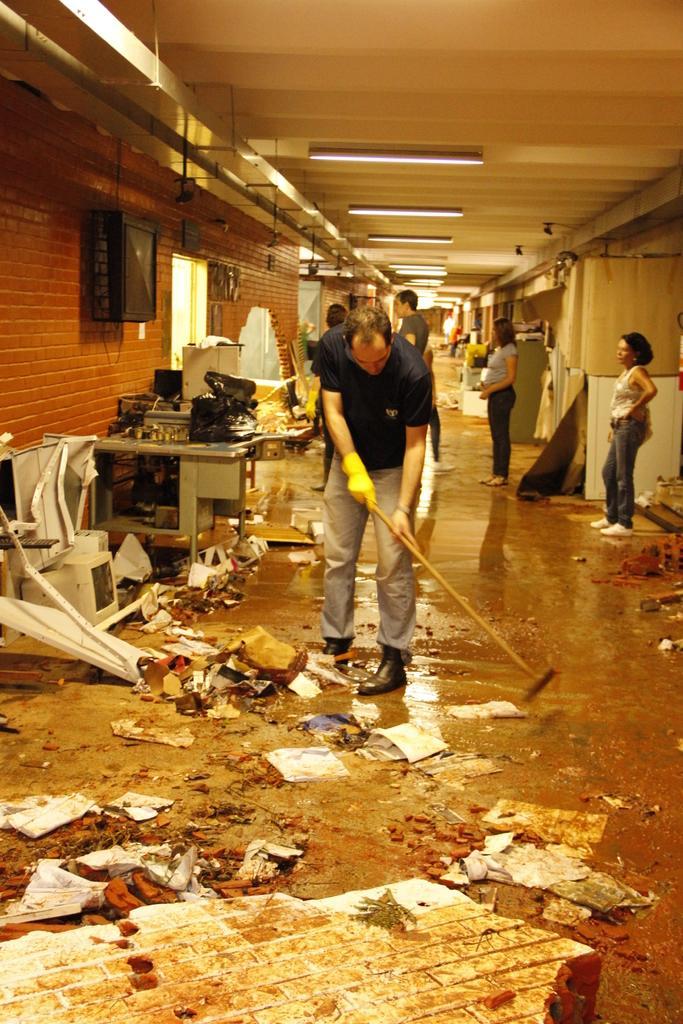Can you describe this image briefly? In this image I can see in the middle, a person is cleaning the floor. At the back side few people are standing, at the top there are lights. On the left side it looks like a t. v. 